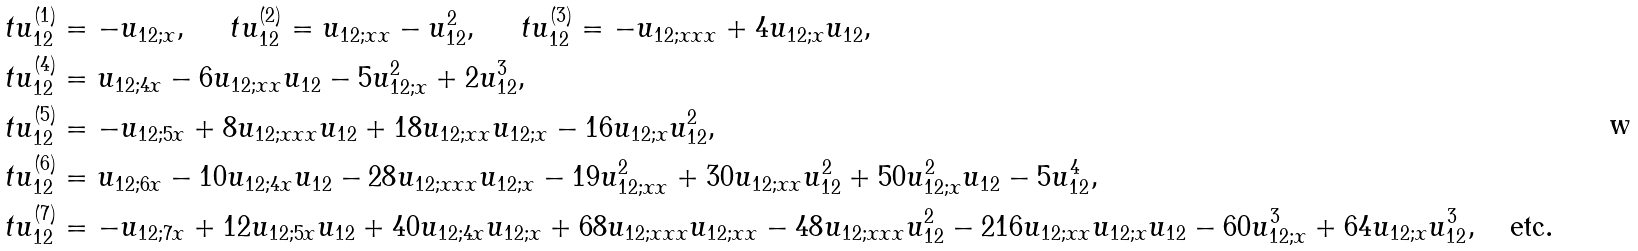<formula> <loc_0><loc_0><loc_500><loc_500>\ t u _ { 1 2 } ^ { ( 1 ) } & = - u _ { 1 2 ; x } , \quad \ t u _ { 1 2 } ^ { ( 2 ) } = u _ { 1 2 ; x x } - u _ { 1 2 } ^ { 2 } , \quad \ t u _ { 1 2 } ^ { ( 3 ) } = - u _ { 1 2 ; x x x } + 4 u _ { 1 2 ; x } u _ { 1 2 } , \\ \ t u _ { 1 2 } ^ { ( 4 ) } & = u _ { 1 2 ; 4 x } - 6 u _ { 1 2 ; x x } u _ { 1 2 } - 5 u _ { 1 2 ; x } ^ { 2 } + 2 u _ { 1 2 } ^ { 3 } , \\ \ t u _ { 1 2 } ^ { ( 5 ) } & = - u _ { 1 2 ; 5 x } + 8 u _ { 1 2 ; x x x } u _ { 1 2 } + 1 8 u _ { 1 2 ; x x } u _ { 1 2 ; x } - 1 6 u _ { 1 2 ; x } u _ { 1 2 } ^ { 2 } , \\ \ t u _ { 1 2 } ^ { ( 6 ) } & = u _ { 1 2 ; 6 x } - 1 0 u _ { 1 2 ; 4 x } u _ { 1 2 } - 2 8 u _ { 1 2 ; x x x } u _ { 1 2 ; x } - 1 9 u _ { 1 2 ; x x } ^ { 2 } + 3 0 u _ { 1 2 ; x x } u _ { 1 2 } ^ { 2 } + 5 0 u _ { 1 2 ; x } ^ { 2 } u _ { 1 2 } - 5 u _ { 1 2 } ^ { 4 } , \\ \ t u _ { 1 2 } ^ { ( 7 ) } & = - u _ { 1 2 ; 7 x } + 1 2 u _ { 1 2 ; 5 x } u _ { 1 2 } + 4 0 u _ { 1 2 ; 4 x } u _ { 1 2 ; x } + 6 8 u _ { 1 2 ; x x x } u _ { 1 2 ; x x } - 4 8 u _ { 1 2 ; x x x } u _ { 1 2 } ^ { 2 } - 2 1 6 u _ { 1 2 ; x x } u _ { 1 2 ; x } u _ { 1 2 } - 6 0 u _ { 1 2 ; x } ^ { 3 } + 6 4 u _ { 1 2 ; x } u _ { 1 2 } ^ { 3 } , \quad \text {etc} .</formula> 